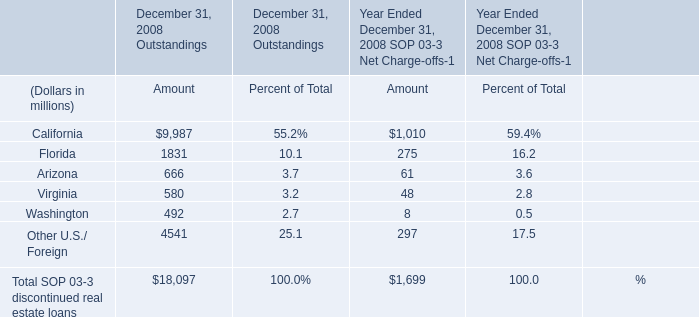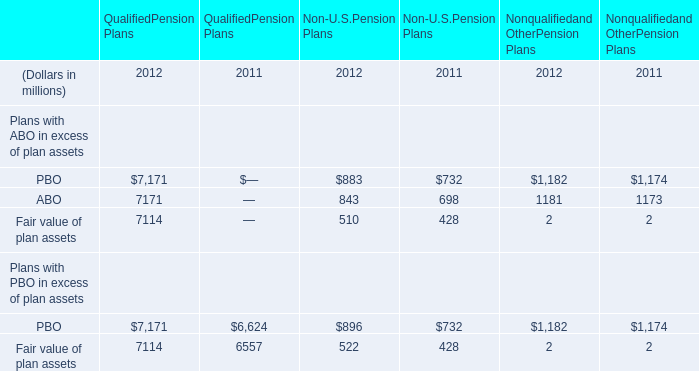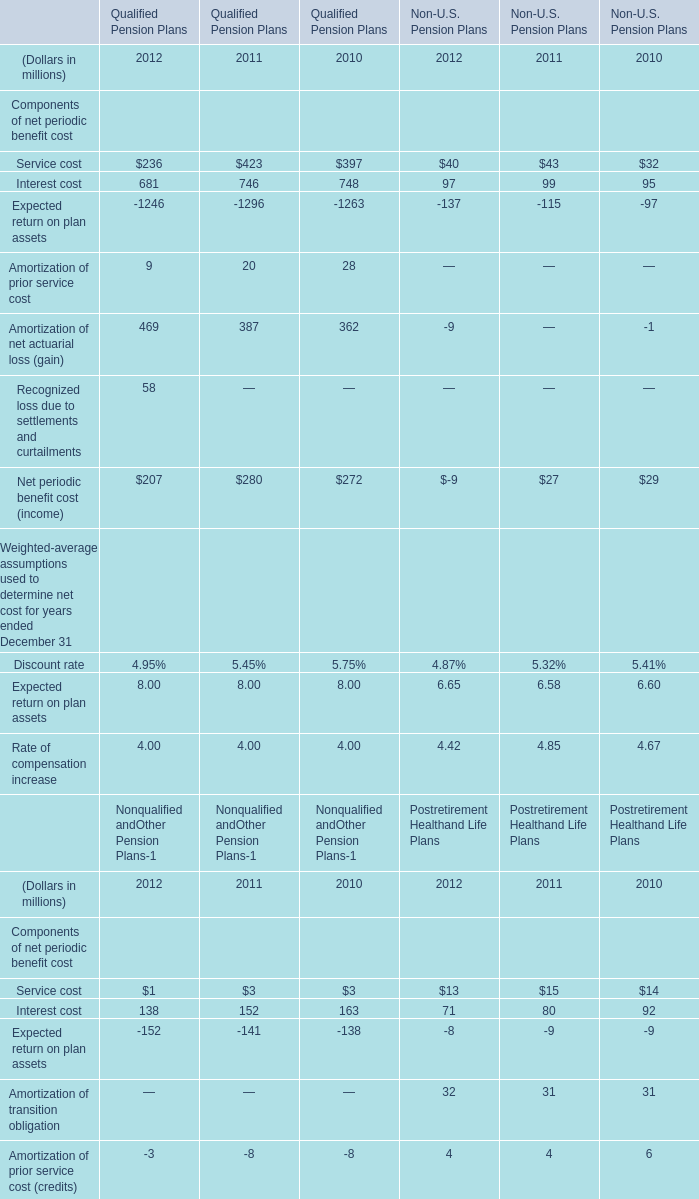What's the sum of PBO of QualifiedPension Plans 2012, and Expected return on plan assets of Qualified Pension Plans 2010 ? 
Computations: (7171.0 + 1263.0)
Answer: 8434.0. 